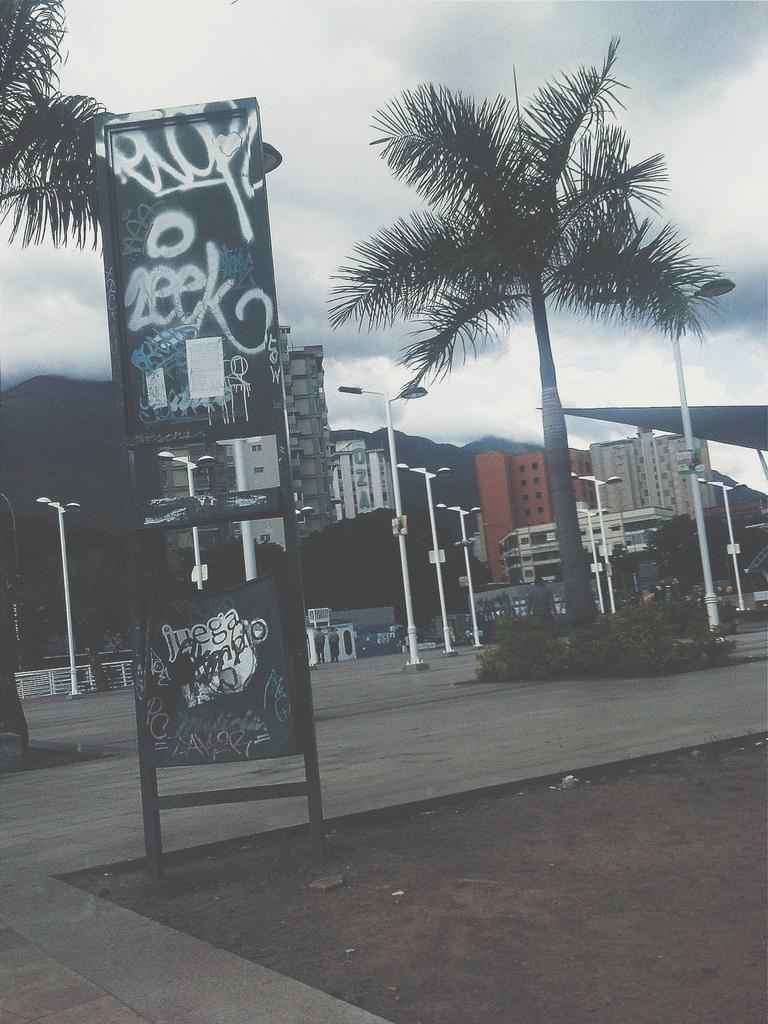What is written on the board in the image? The facts do not specify the text on the board, so we cannot answer this question definitively. What type of vegetation can be seen in the image? There are trees and plants in the image. What type of structures are visible in the image? There is a group of buildings in the image. What are the street poles used for in the image? The facts do not specify the purpose of the street poles, so we cannot answer this question definitively. What natural features can be seen in the image? The hills are visible in the image. What is the weather like in the image? The sky is cloudy in the image. What type of mint is growing in the image? There is no mint present in the image. Can you see any cheese in the image? There is no cheese present in the image. 